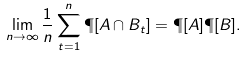<formula> <loc_0><loc_0><loc_500><loc_500>\lim _ { n \to \infty } \frac { 1 } { n } \sum _ { t = 1 } ^ { n } \P [ A \cap B _ { t } ] = \P [ A ] \P [ B ] .</formula> 